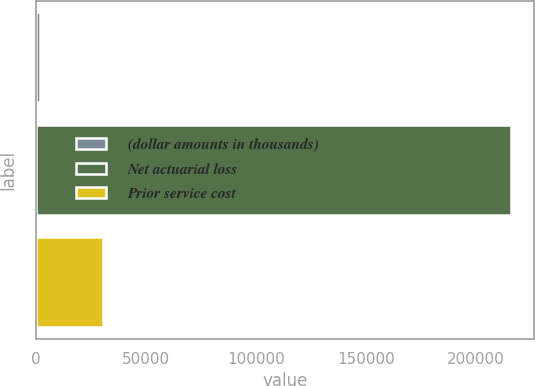<chart> <loc_0><loc_0><loc_500><loc_500><bar_chart><fcel>(dollar amounts in thousands)<fcel>Net actuarial loss<fcel>Prior service cost<nl><fcel>2011<fcel>215628<fcel>30261<nl></chart> 